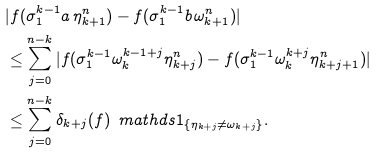Convert formula to latex. <formula><loc_0><loc_0><loc_500><loc_500>& | f ( \sigma _ { 1 } ^ { k - 1 } a \, \eta _ { k + 1 } ^ { n } ) - f ( \sigma _ { 1 } ^ { k - 1 } b \, \omega _ { k + 1 } ^ { n } ) | \\ & \leq \sum _ { j = 0 } ^ { n - k } | f ( \sigma _ { 1 } ^ { k - 1 } \omega _ { k } ^ { k - 1 + j } \eta _ { k + j } ^ { n } ) - f ( \sigma _ { 1 } ^ { k - 1 } \omega _ { k } ^ { k + j } \eta _ { k + j + 1 } ^ { n } ) | \\ & \leq \sum _ { j = 0 } ^ { n - k } \delta _ { k + j } ( f ) \, \ m a t h d s { 1 } _ { \{ \eta _ { k + j } \neq \omega _ { k + j } \} } .</formula> 